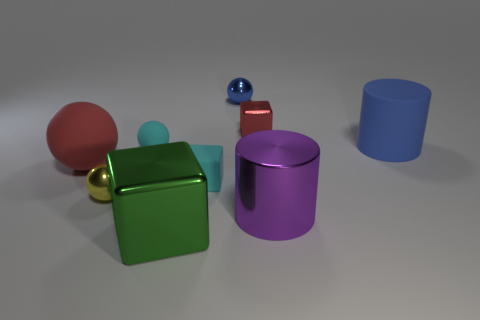Add 1 large blue rubber objects. How many objects exist? 10 Subtract all tiny yellow metal balls. How many balls are left? 3 Subtract all cyan spheres. How many spheres are left? 3 Subtract 1 cubes. How many cubes are left? 2 Subtract all cubes. How many objects are left? 6 Subtract all small cyan balls. Subtract all red metallic cubes. How many objects are left? 7 Add 6 green blocks. How many green blocks are left? 7 Add 4 large red matte cylinders. How many large red matte cylinders exist? 4 Subtract 0 green spheres. How many objects are left? 9 Subtract all gray cylinders. Subtract all blue spheres. How many cylinders are left? 2 